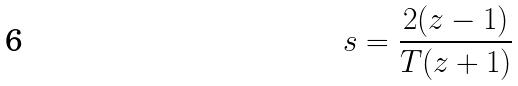<formula> <loc_0><loc_0><loc_500><loc_500>s = \frac { 2 ( z - 1 ) } { T ( z + 1 ) }</formula> 